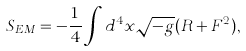<formula> <loc_0><loc_0><loc_500><loc_500>S _ { E M } = - \frac { 1 } { 4 } \int d ^ { 4 } x \sqrt { - g } ( R + F ^ { 2 } ) ,</formula> 